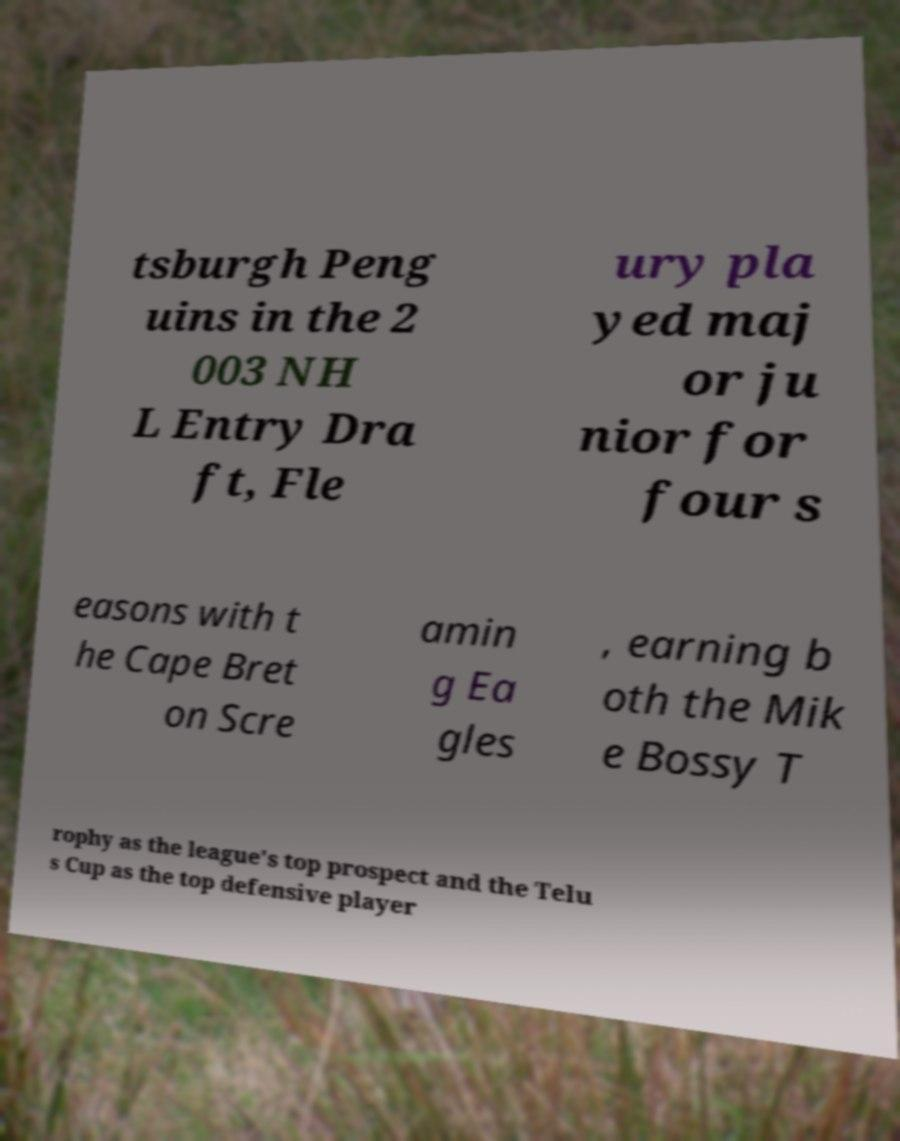Could you extract and type out the text from this image? tsburgh Peng uins in the 2 003 NH L Entry Dra ft, Fle ury pla yed maj or ju nior for four s easons with t he Cape Bret on Scre amin g Ea gles , earning b oth the Mik e Bossy T rophy as the league's top prospect and the Telu s Cup as the top defensive player 